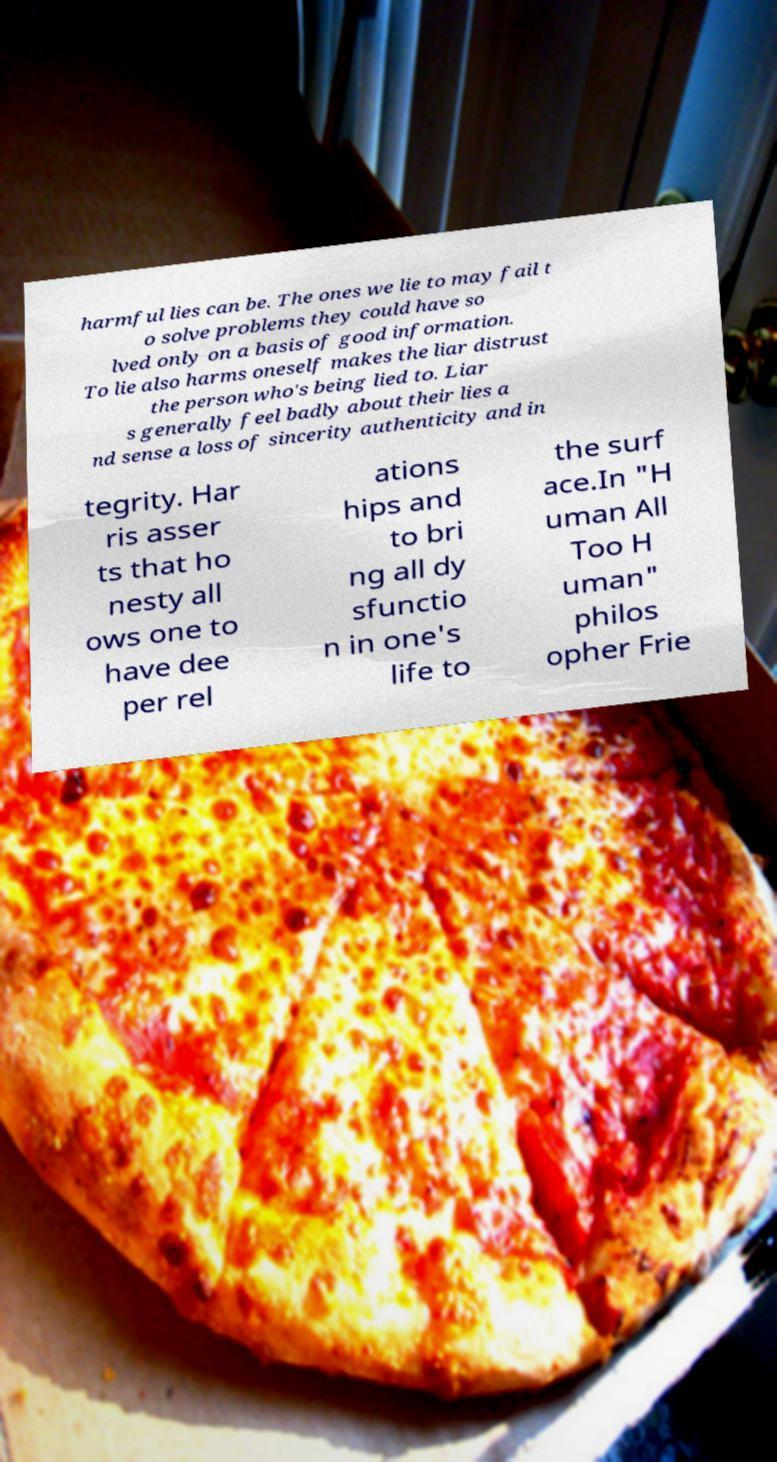Please read and relay the text visible in this image. What does it say? harmful lies can be. The ones we lie to may fail t o solve problems they could have so lved only on a basis of good information. To lie also harms oneself makes the liar distrust the person who's being lied to. Liar s generally feel badly about their lies a nd sense a loss of sincerity authenticity and in tegrity. Har ris asser ts that ho nesty all ows one to have dee per rel ations hips and to bri ng all dy sfunctio n in one's life to the surf ace.In "H uman All Too H uman" philos opher Frie 